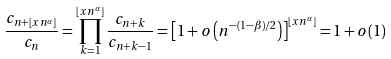Convert formula to latex. <formula><loc_0><loc_0><loc_500><loc_500>\frac { c _ { n + \lfloor x n ^ { \alpha } \rfloor } } { c _ { n } } = \prod _ { k = 1 } ^ { \lfloor x n ^ { \alpha } \rfloor } \frac { c _ { n + k } } { c _ { n + k - 1 } } = \left [ 1 + o \left ( n ^ { - ( 1 - \beta ) / 2 } \right ) \right ] ^ { \lfloor x n ^ { \alpha } \rfloor } = 1 + o ( 1 )</formula> 